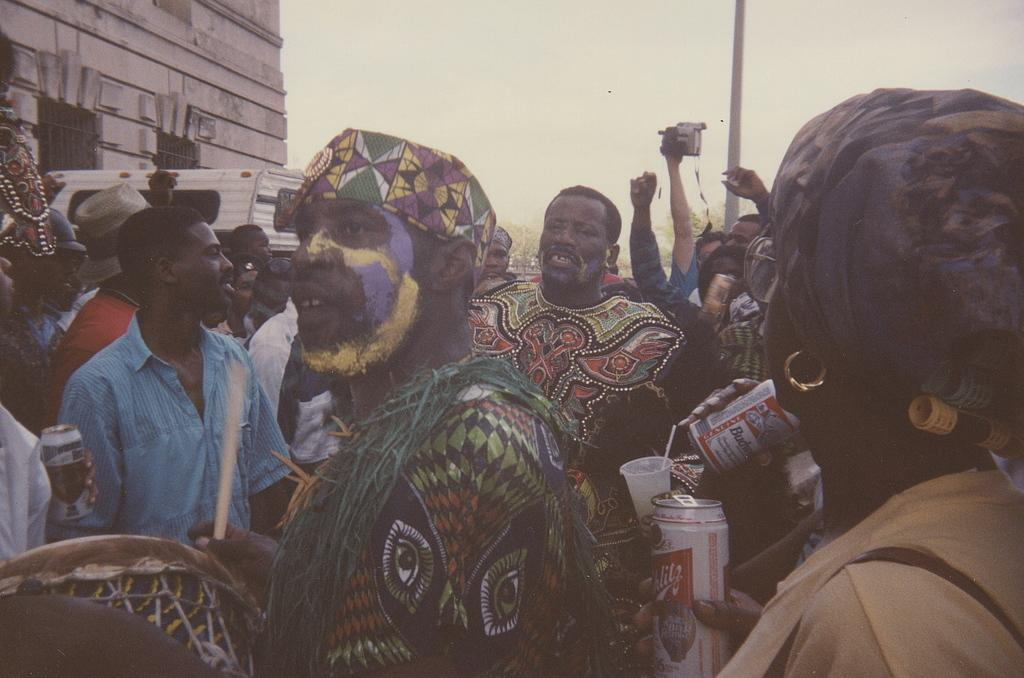Who is the main subject in the middle of the image? There is a man in the middle of the image. What is the woman wearing on the right side of the image? The woman is wearing a t-shirt and headwear. How many people are visible in the image? There are other people standing in the image, in addition to the man and woman. What is visible at the top of the image? The sky is visible at the top of the image. What type of toe is visible in the image? There are no visible toes in the image. What is the woman eating while on her journey in the image? There is no journey or eating depicted in the image; it simply shows a man and a woman standing with other people. 